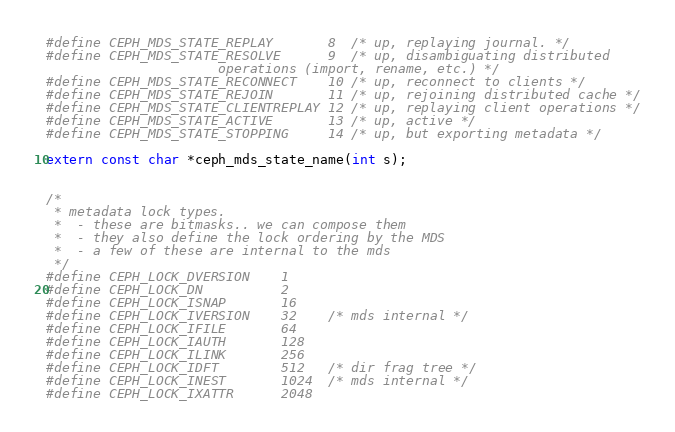Convert code to text. <code><loc_0><loc_0><loc_500><loc_500><_C_>#define CEPH_MDS_STATE_REPLAY       8  /* up, replaying journal. */
#define CEPH_MDS_STATE_RESOLVE      9  /* up, disambiguating distributed
					  operations (import, rename, etc.) */
#define CEPH_MDS_STATE_RECONNECT    10 /* up, reconnect to clients */
#define CEPH_MDS_STATE_REJOIN       11 /* up, rejoining distributed cache */
#define CEPH_MDS_STATE_CLIENTREPLAY 12 /* up, replaying client operations */
#define CEPH_MDS_STATE_ACTIVE       13 /* up, active */
#define CEPH_MDS_STATE_STOPPING     14 /* up, but exporting metadata */

extern const char *ceph_mds_state_name(int s);


/*
 * metadata lock types.
 *  - these are bitmasks.. we can compose them
 *  - they also define the lock ordering by the MDS
 *  - a few of these are internal to the mds
 */
#define CEPH_LOCK_DVERSION    1
#define CEPH_LOCK_DN          2
#define CEPH_LOCK_ISNAP       16
#define CEPH_LOCK_IVERSION    32    /* mds internal */
#define CEPH_LOCK_IFILE       64
#define CEPH_LOCK_IAUTH       128
#define CEPH_LOCK_ILINK       256
#define CEPH_LOCK_IDFT        512   /* dir frag tree */
#define CEPH_LOCK_INEST       1024  /* mds internal */
#define CEPH_LOCK_IXATTR      2048</code> 